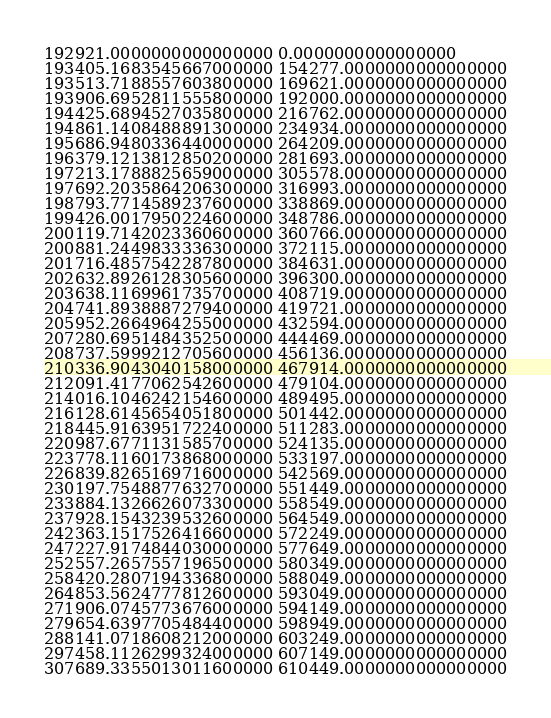Convert code to text. <code><loc_0><loc_0><loc_500><loc_500><_FORTRAN_>192921.0000000000000000 0.0000000000000000
193405.1683545667000000 154277.0000000000000000
193513.7188557603800000 169621.0000000000000000
193906.6952811555800000 192000.0000000000000000
194425.6894527035800000 216762.0000000000000000
194861.1408488891300000 234934.0000000000000000
195686.9480336440000000 264209.0000000000000000
196379.1213812850200000 281693.0000000000000000
197213.1788825659000000 305578.0000000000000000
197692.2035864206300000 316993.0000000000000000
198793.7714589237600000 338869.0000000000000000
199426.0017950224600000 348786.0000000000000000
200119.7142023360600000 360766.0000000000000000
200881.2449833336300000 372115.0000000000000000
201716.4857542287800000 384631.0000000000000000
202632.8926128305600000 396300.0000000000000000
203638.1169961735700000 408719.0000000000000000
204741.8938887279400000 419721.0000000000000000
205952.2664964255000000 432594.0000000000000000
207280.6951484352500000 444469.0000000000000000
208737.5999212705600000 456136.0000000000000000
210336.9043040158000000 467914.0000000000000000
212091.4177062542600000 479104.0000000000000000
214016.1046242154600000 489495.0000000000000000
216128.6145654051800000 501442.0000000000000000
218445.9163951722400000 511283.0000000000000000
220987.6771131585700000 524135.0000000000000000
223778.1160173868000000 533197.0000000000000000
226839.8265169716000000 542569.0000000000000000
230197.7548877632700000 551449.0000000000000000
233884.1326626073300000 558549.0000000000000000
237928.1543239532600000 564549.0000000000000000
242363.1517526416600000 572249.0000000000000000
247227.9174844030000000 577649.0000000000000000
252557.2657557196500000 580349.0000000000000000
258420.2807194336800000 588049.0000000000000000
264853.5624777812600000 593049.0000000000000000
271906.0745773676000000 594149.0000000000000000
279654.6397705484400000 598949.0000000000000000
288141.0718608212000000 603249.0000000000000000
297458.1126299324000000 607149.0000000000000000
307689.3355013011600000 610449.0000000000000000</code> 